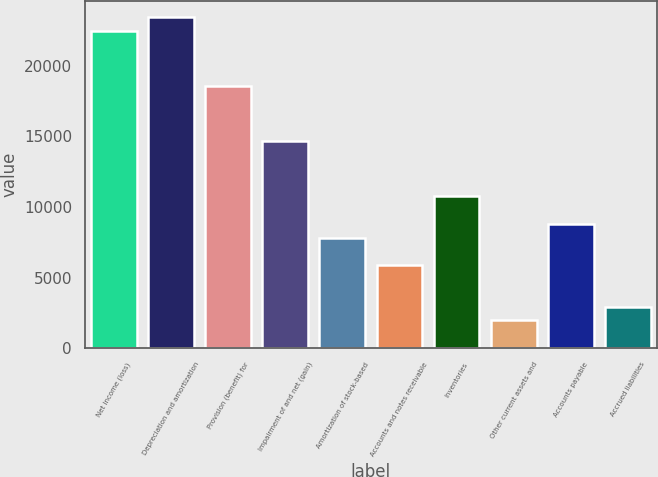Convert chart. <chart><loc_0><loc_0><loc_500><loc_500><bar_chart><fcel>Net income (loss)<fcel>Depreciation and amortization<fcel>Provision (benefit) for<fcel>Impairment of and net (gain)<fcel>Amortization of stock-based<fcel>Accounts and notes receivable<fcel>Inventories<fcel>Other current assets and<fcel>Accounts payable<fcel>Accrued liabilities<nl><fcel>22474.3<fcel>23451.4<fcel>18565.9<fcel>14657.5<fcel>7817.8<fcel>5863.6<fcel>10749.1<fcel>1955.2<fcel>8794.9<fcel>2932.3<nl></chart> 